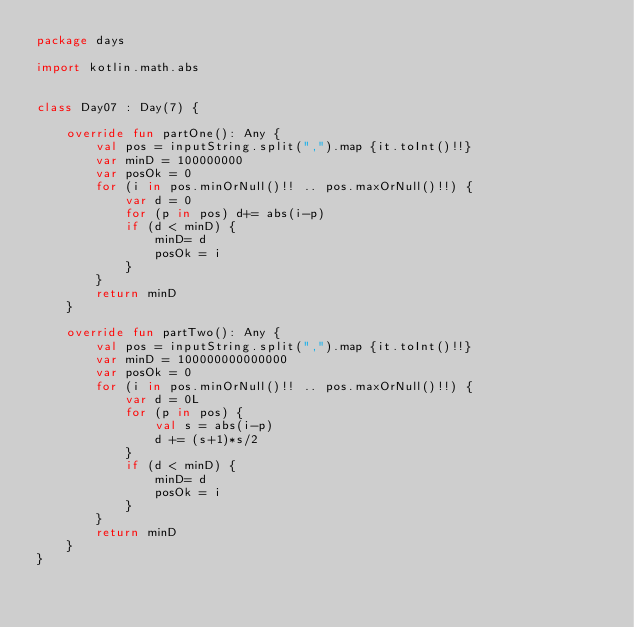<code> <loc_0><loc_0><loc_500><loc_500><_Kotlin_>package days

import kotlin.math.abs


class Day07 : Day(7) {

    override fun partOne(): Any {
        val pos = inputString.split(",").map {it.toInt()!!}
        var minD = 100000000
        var posOk = 0
        for (i in pos.minOrNull()!! .. pos.maxOrNull()!!) {
            var d = 0
            for (p in pos) d+= abs(i-p)
            if (d < minD) {
                minD= d
                posOk = i
            }
        }
        return minD
    }

    override fun partTwo(): Any {
        val pos = inputString.split(",").map {it.toInt()!!}
        var minD = 100000000000000
        var posOk = 0
        for (i in pos.minOrNull()!! .. pos.maxOrNull()!!) {
            var d = 0L
            for (p in pos) {
                val s = abs(i-p)
                d += (s+1)*s/2
            }
            if (d < minD) {
                minD= d
                posOk = i
            }
        }
        return minD
    }
}
</code> 